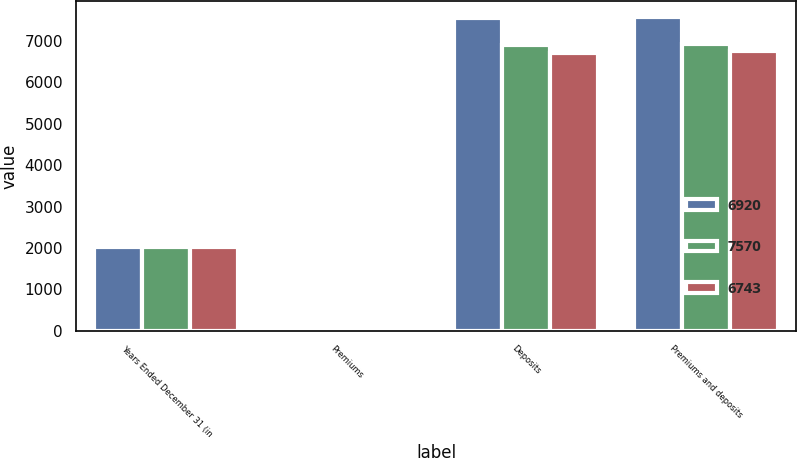Convert chart to OTSL. <chart><loc_0><loc_0><loc_500><loc_500><stacked_bar_chart><ecel><fcel>Years Ended December 31 (in<fcel>Premiums<fcel>Deposits<fcel>Premiums and deposits<nl><fcel>6920<fcel>2016<fcel>27<fcel>7543<fcel>7570<nl><fcel>7570<fcel>2015<fcel>22<fcel>6899<fcel>6920<nl><fcel>6743<fcel>2014<fcel>44<fcel>6699<fcel>6743<nl></chart> 